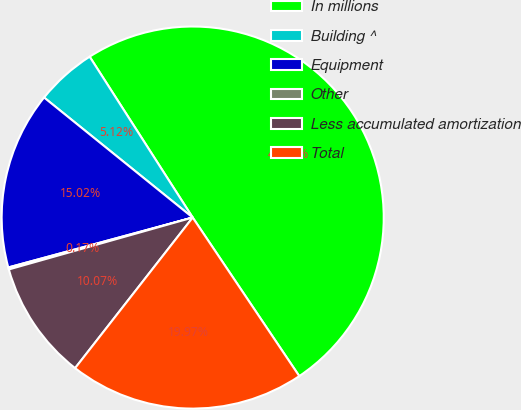Convert chart. <chart><loc_0><loc_0><loc_500><loc_500><pie_chart><fcel>In millions<fcel>Building ^<fcel>Equipment<fcel>Other<fcel>Less accumulated amortization<fcel>Total<nl><fcel>49.65%<fcel>5.12%<fcel>15.02%<fcel>0.17%<fcel>10.07%<fcel>19.97%<nl></chart> 